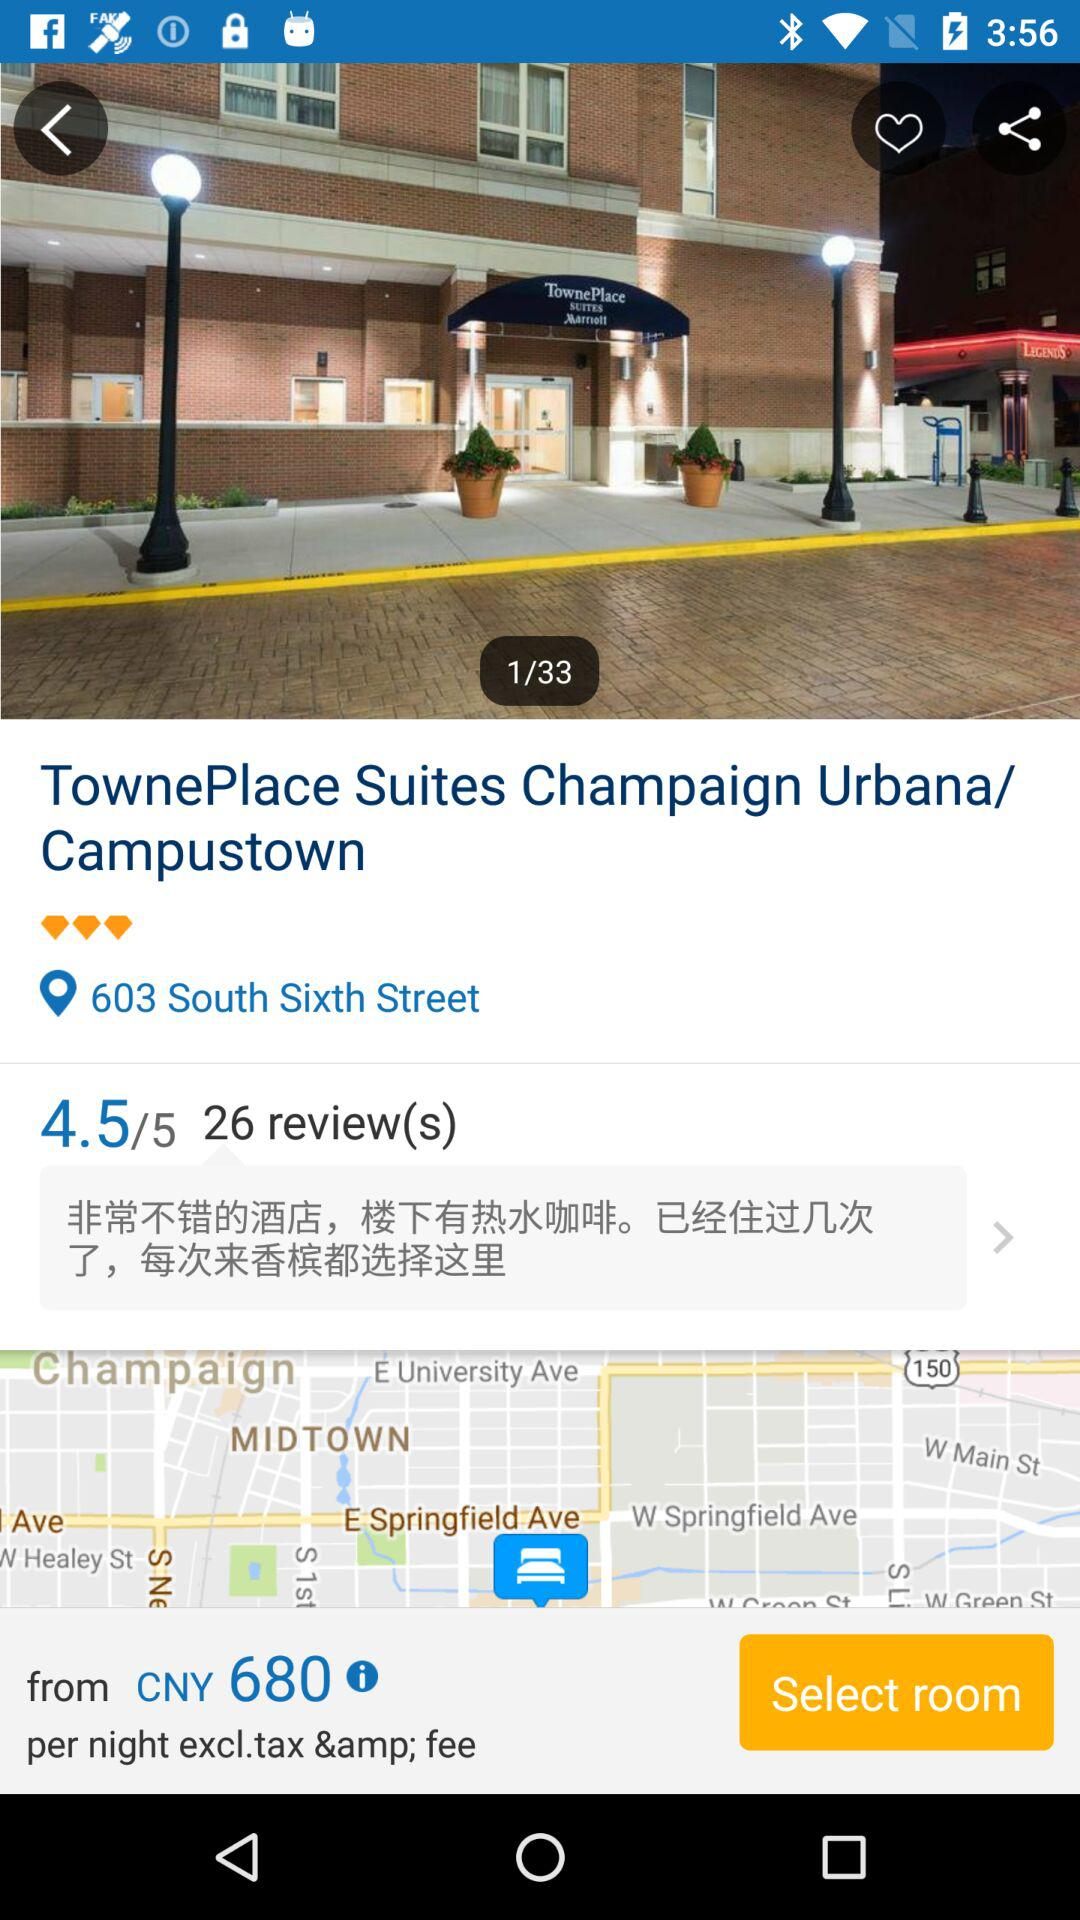How many reviews does this hotel have?
Answer the question using a single word or phrase. 26 